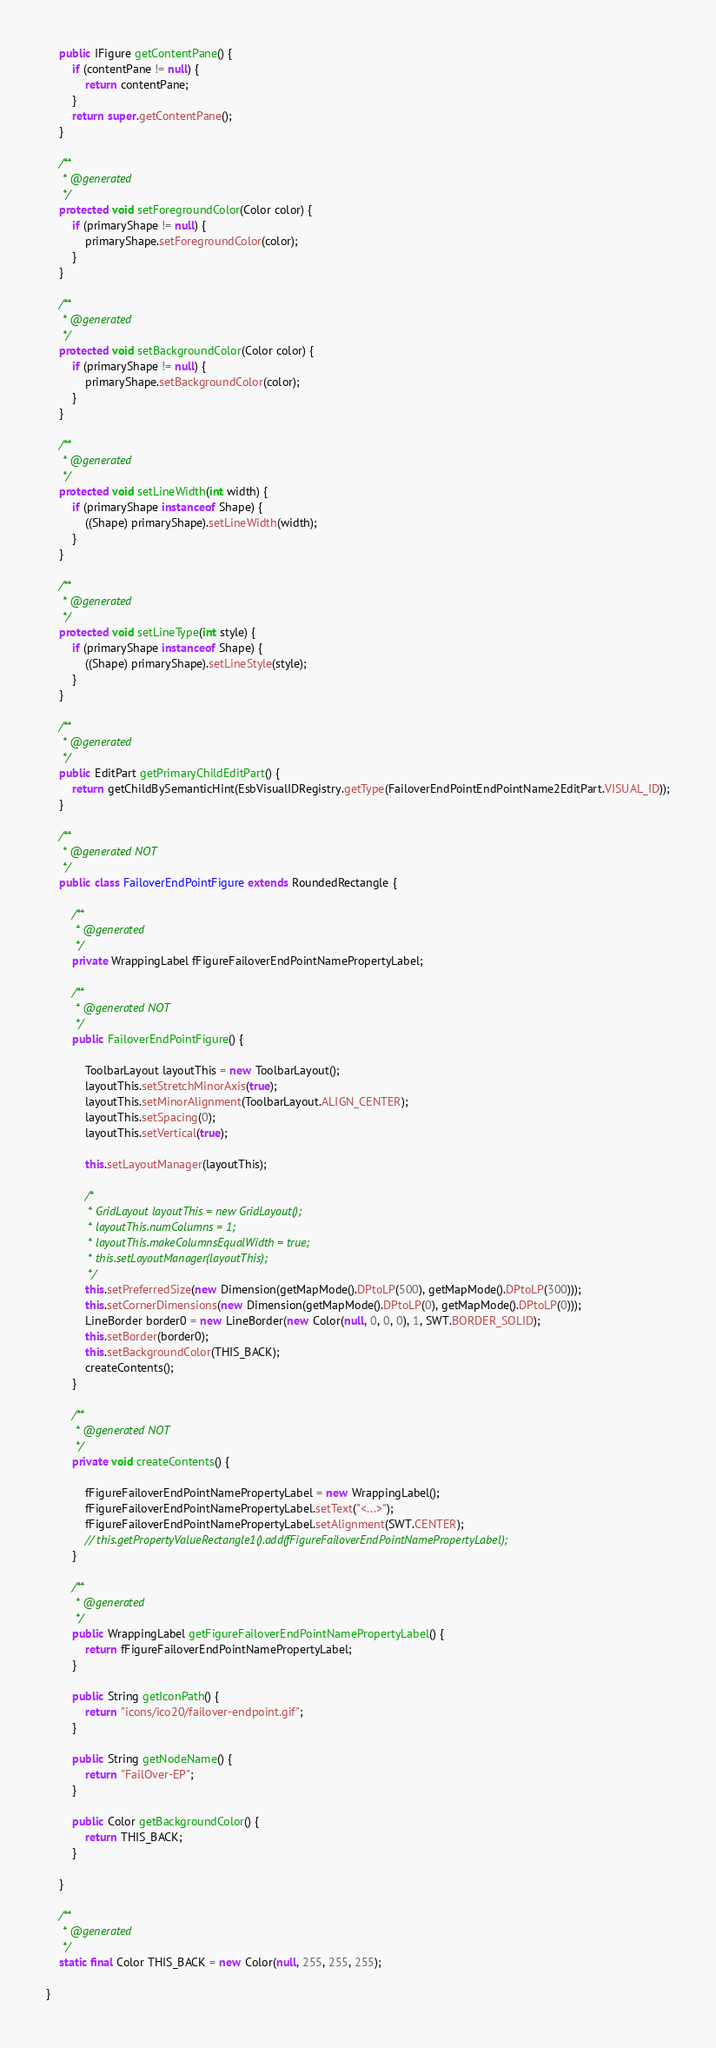<code> <loc_0><loc_0><loc_500><loc_500><_Java_>    public IFigure getContentPane() {
        if (contentPane != null) {
            return contentPane;
        }
        return super.getContentPane();
    }

    /**
     * @generated
     */
    protected void setForegroundColor(Color color) {
        if (primaryShape != null) {
            primaryShape.setForegroundColor(color);
        }
    }

    /**
     * @generated
     */
    protected void setBackgroundColor(Color color) {
        if (primaryShape != null) {
            primaryShape.setBackgroundColor(color);
        }
    }

    /**
     * @generated
     */
    protected void setLineWidth(int width) {
        if (primaryShape instanceof Shape) {
            ((Shape) primaryShape).setLineWidth(width);
        }
    }

    /**
     * @generated
     */
    protected void setLineType(int style) {
        if (primaryShape instanceof Shape) {
            ((Shape) primaryShape).setLineStyle(style);
        }
    }

    /**
     * @generated
     */
    public EditPart getPrimaryChildEditPart() {
        return getChildBySemanticHint(EsbVisualIDRegistry.getType(FailoverEndPointEndPointName2EditPart.VISUAL_ID));
    }

    /**
     * @generated NOT
     */
    public class FailoverEndPointFigure extends RoundedRectangle {

        /**
         * @generated
         */
        private WrappingLabel fFigureFailoverEndPointNamePropertyLabel;

        /**
         * @generated NOT
         */
        public FailoverEndPointFigure() {

            ToolbarLayout layoutThis = new ToolbarLayout();
            layoutThis.setStretchMinorAxis(true);
            layoutThis.setMinorAlignment(ToolbarLayout.ALIGN_CENTER);
            layoutThis.setSpacing(0);
            layoutThis.setVertical(true);

            this.setLayoutManager(layoutThis);

            /*
             * GridLayout layoutThis = new GridLayout();
             * layoutThis.numColumns = 1;
             * layoutThis.makeColumnsEqualWidth = true;
             * this.setLayoutManager(layoutThis);
             */
            this.setPreferredSize(new Dimension(getMapMode().DPtoLP(500), getMapMode().DPtoLP(300)));
            this.setCornerDimensions(new Dimension(getMapMode().DPtoLP(0), getMapMode().DPtoLP(0)));
            LineBorder border0 = new LineBorder(new Color(null, 0, 0, 0), 1, SWT.BORDER_SOLID);
            this.setBorder(border0);
            this.setBackgroundColor(THIS_BACK);
            createContents();
        }

        /**
         * @generated NOT
         */
        private void createContents() {

            fFigureFailoverEndPointNamePropertyLabel = new WrappingLabel();
            fFigureFailoverEndPointNamePropertyLabel.setText("<...>");
            fFigureFailoverEndPointNamePropertyLabel.setAlignment(SWT.CENTER);
            // this.getPropertyValueRectangle1().add(fFigureFailoverEndPointNamePropertyLabel);
        }

        /**
         * @generated
         */
        public WrappingLabel getFigureFailoverEndPointNamePropertyLabel() {
            return fFigureFailoverEndPointNamePropertyLabel;
        }

        public String getIconPath() {
            return "icons/ico20/failover-endpoint.gif";
        }

        public String getNodeName() {
            return "FailOver-EP";
        }

        public Color getBackgroundColor() {
            return THIS_BACK;
        }

    }

    /**
     * @generated
     */
    static final Color THIS_BACK = new Color(null, 255, 255, 255);

}</code> 